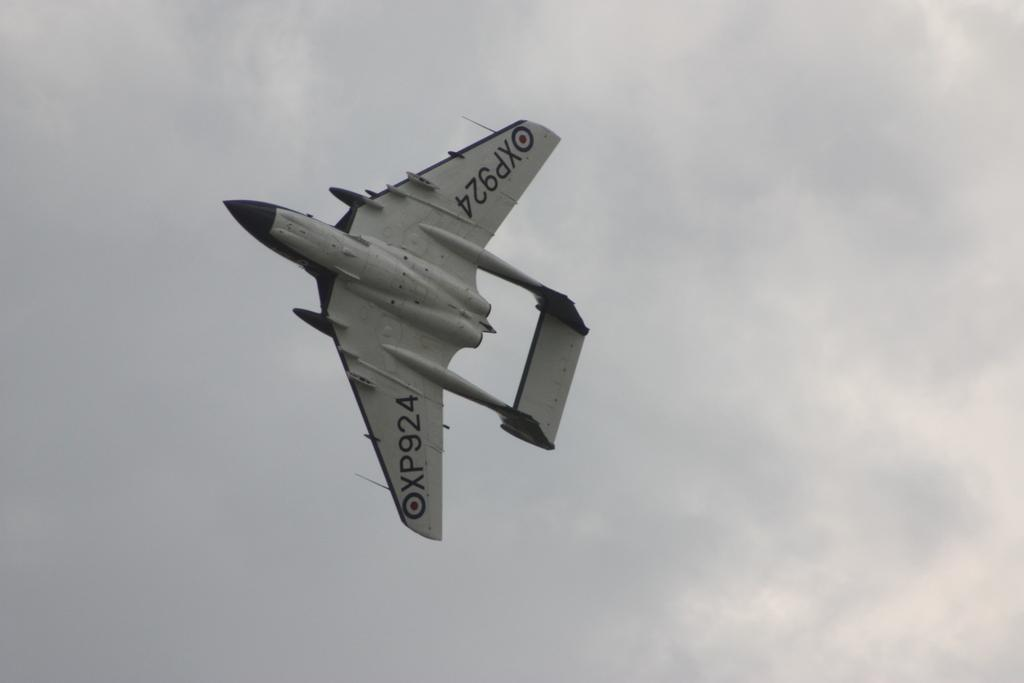Provide a one-sentence caption for the provided image. XP924 airplane taking flight in the sky near the clouds. 